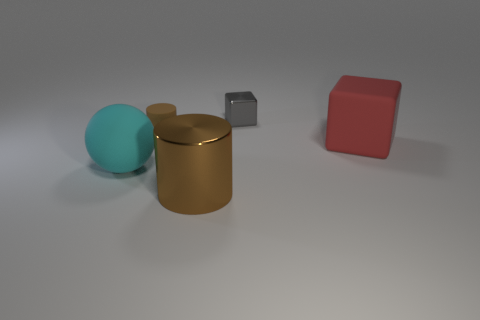How many shiny objects are gray things or large cyan objects?
Ensure brevity in your answer.  1. Does the tiny gray object that is left of the matte block have the same shape as the big rubber thing that is on the right side of the small rubber cylinder?
Your answer should be compact. Yes. There is a thing that is on the left side of the small block and behind the large cyan rubber ball; what is its color?
Offer a very short reply. Brown. There is a brown cylinder that is to the right of the small matte thing; does it have the same size as the matte thing behind the large red block?
Provide a short and direct response. No. What number of small rubber objects are the same color as the shiny cylinder?
Ensure brevity in your answer.  1. How many large things are either brown rubber things or cylinders?
Your response must be concise. 1. Do the brown cylinder that is behind the big red object and the red cube have the same material?
Offer a terse response. Yes. The big object in front of the big cyan thing is what color?
Your answer should be very brief. Brown. Are there any brown matte objects that have the same size as the metal cube?
Give a very brief answer. Yes. What is the material of the red object that is the same size as the shiny cylinder?
Your answer should be very brief. Rubber. 